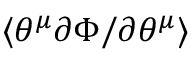<formula> <loc_0><loc_0><loc_500><loc_500>\langle \theta ^ { \mu } \partial \Phi / \partial \theta ^ { \mu } \rangle</formula> 